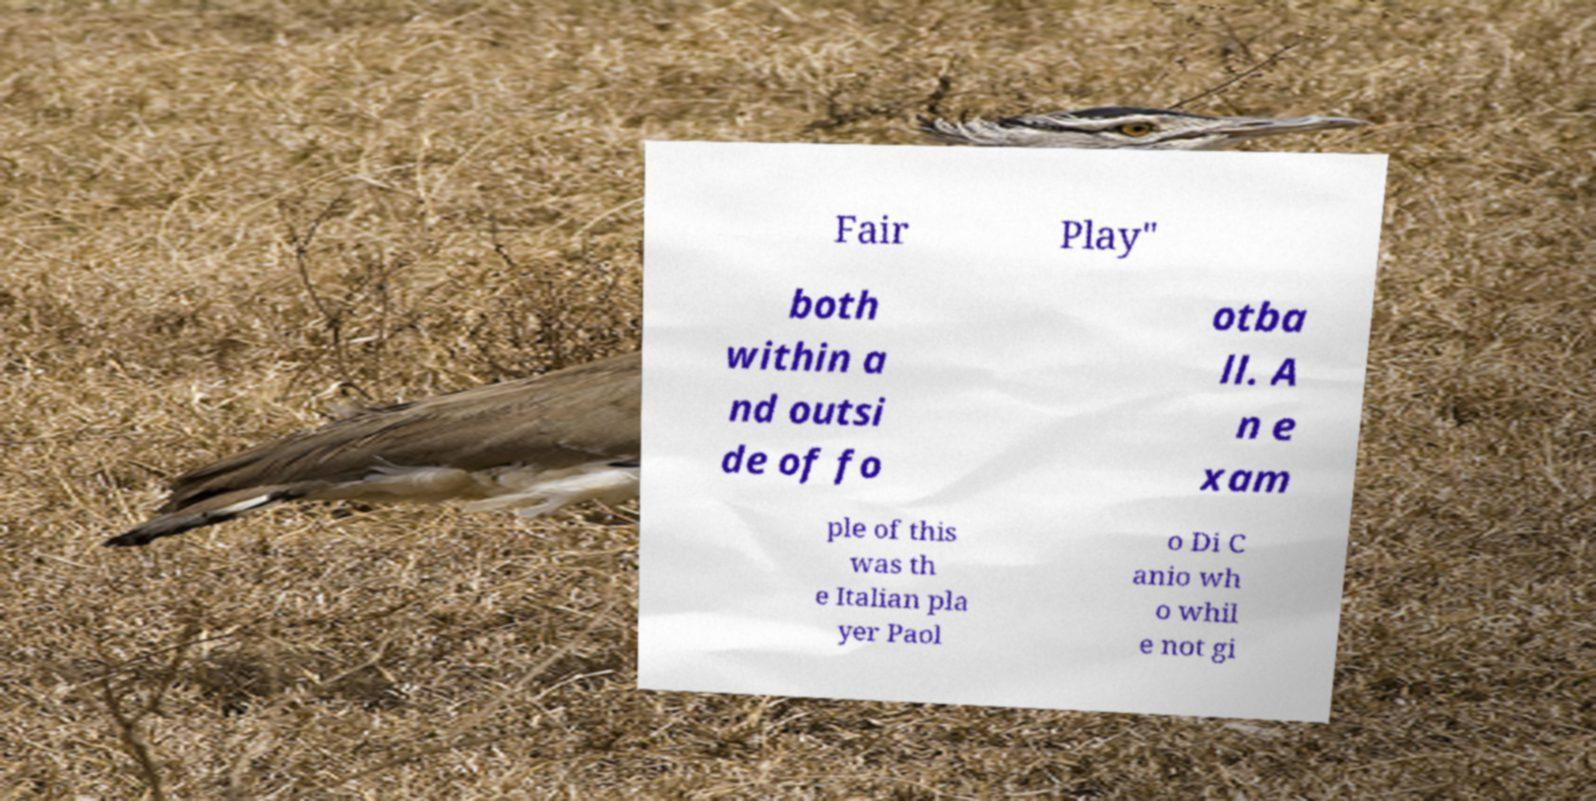Could you assist in decoding the text presented in this image and type it out clearly? Fair Play" both within a nd outsi de of fo otba ll. A n e xam ple of this was th e Italian pla yer Paol o Di C anio wh o whil e not gi 